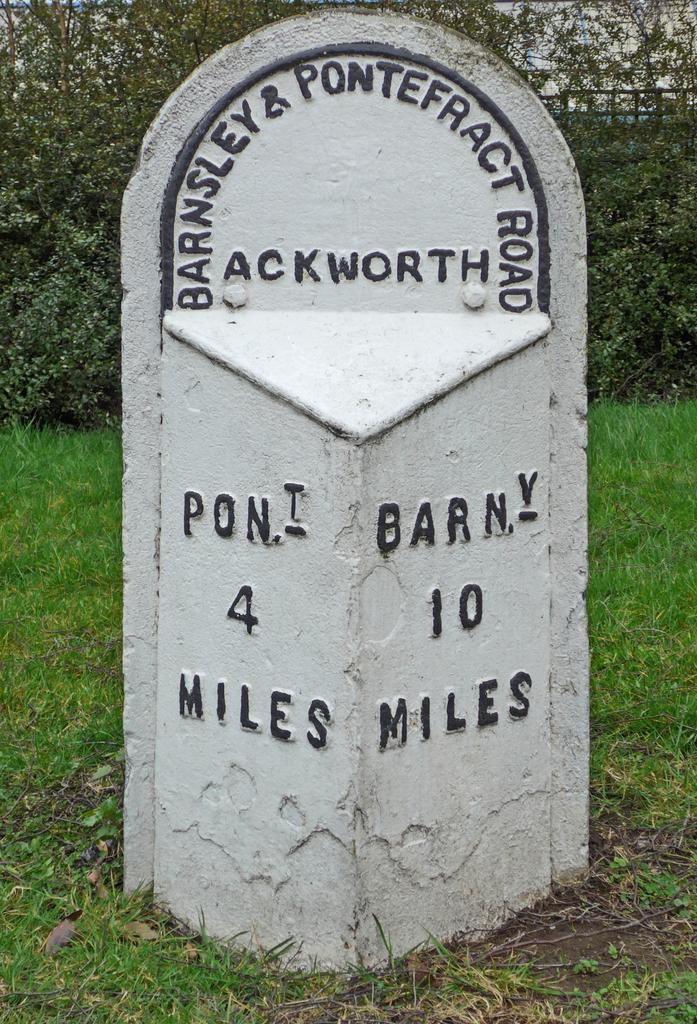What is written or depicted on the stone in the image? There is text on a stone in the image. What type of natural environment can be seen in the background? There are trees visible in the background. What type of barrier is present in the image? There is a wooden railing in the image. What is visible at the top of the image? The sky is visible at the top of the image. What type of ground surface is present at the bottom of the image? Grass is present at the bottom of the image. How does the ladybug open the gate in the image? There is no ladybug or gate present in the image. What type of lift is visible in the image? There is no lift present in the image. 